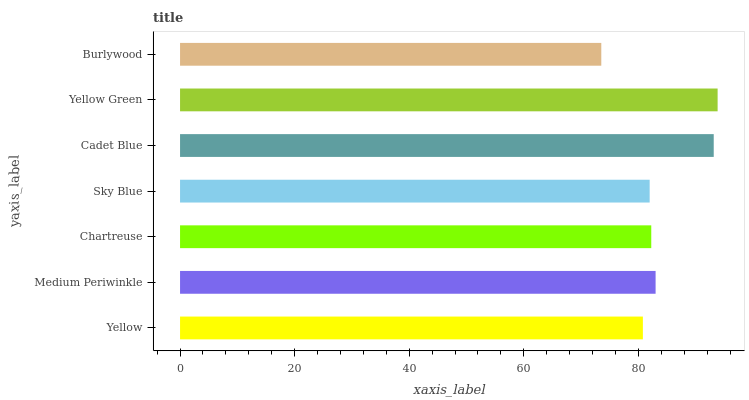Is Burlywood the minimum?
Answer yes or no. Yes. Is Yellow Green the maximum?
Answer yes or no. Yes. Is Medium Periwinkle the minimum?
Answer yes or no. No. Is Medium Periwinkle the maximum?
Answer yes or no. No. Is Medium Periwinkle greater than Yellow?
Answer yes or no. Yes. Is Yellow less than Medium Periwinkle?
Answer yes or no. Yes. Is Yellow greater than Medium Periwinkle?
Answer yes or no. No. Is Medium Periwinkle less than Yellow?
Answer yes or no. No. Is Chartreuse the high median?
Answer yes or no. Yes. Is Chartreuse the low median?
Answer yes or no. Yes. Is Yellow Green the high median?
Answer yes or no. No. Is Yellow the low median?
Answer yes or no. No. 